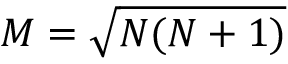Convert formula to latex. <formula><loc_0><loc_0><loc_500><loc_500>M = \sqrt { N ( N + 1 ) }</formula> 